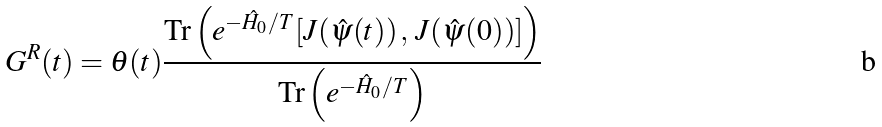Convert formula to latex. <formula><loc_0><loc_0><loc_500><loc_500>G ^ { R } ( t ) = \theta ( t ) \frac { \text {Tr} \left ( e ^ { - \hat { H } _ { 0 } / T } [ J ( \hat { \psi } ( t ) ) \, , \, J ( \hat { \psi } ( 0 ) ) ] \right ) } { \text {Tr} \left ( e ^ { - \hat { H } _ { 0 } / T } \right ) } \,</formula> 